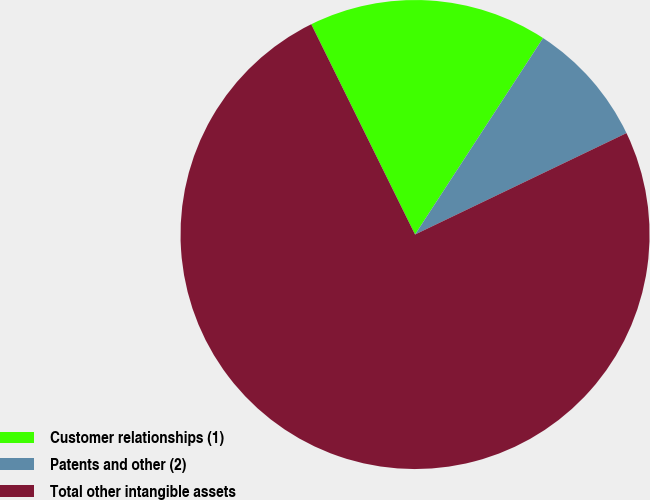<chart> <loc_0><loc_0><loc_500><loc_500><pie_chart><fcel>Customer relationships (1)<fcel>Patents and other (2)<fcel>Total other intangible assets<nl><fcel>16.49%<fcel>8.69%<fcel>74.82%<nl></chart> 